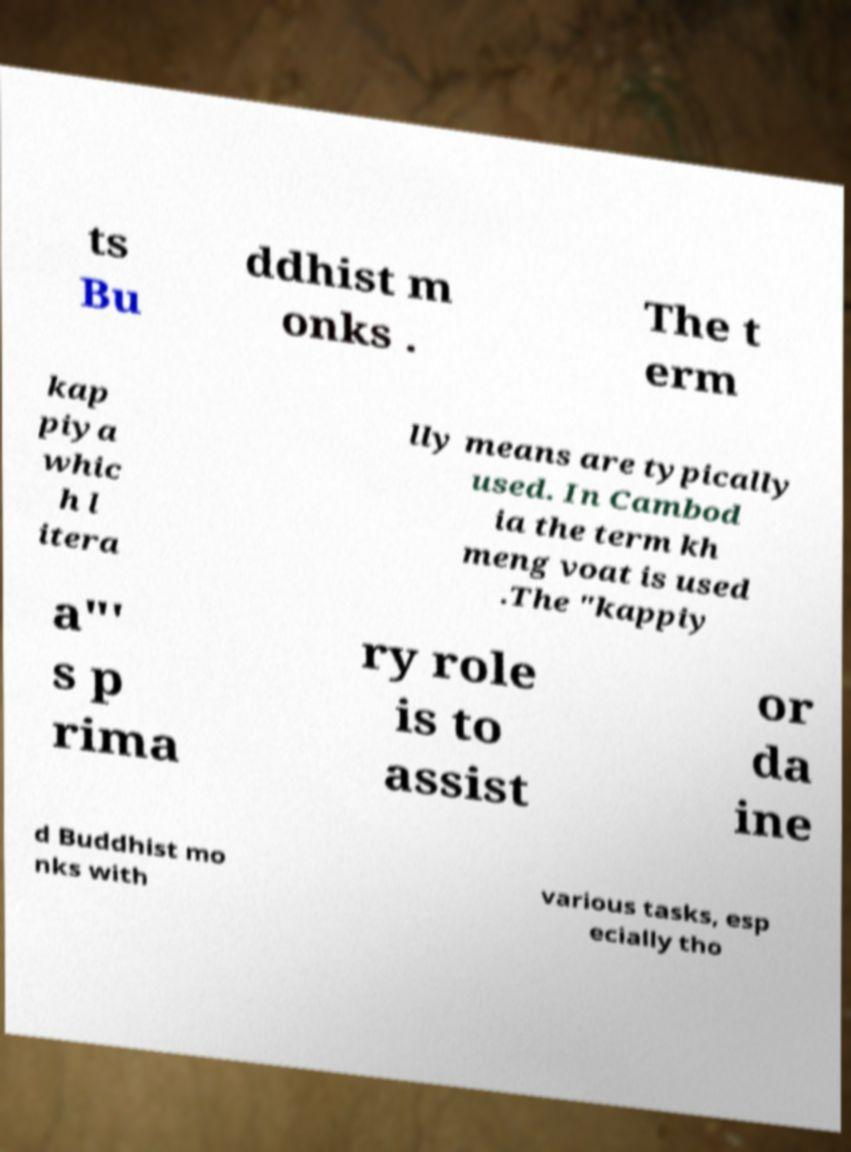There's text embedded in this image that I need extracted. Can you transcribe it verbatim? ts Bu ddhist m onks . The t erm kap piya whic h l itera lly means are typically used. In Cambod ia the term kh meng voat is used .The "kappiy a"' s p rima ry role is to assist or da ine d Buddhist mo nks with various tasks, esp ecially tho 